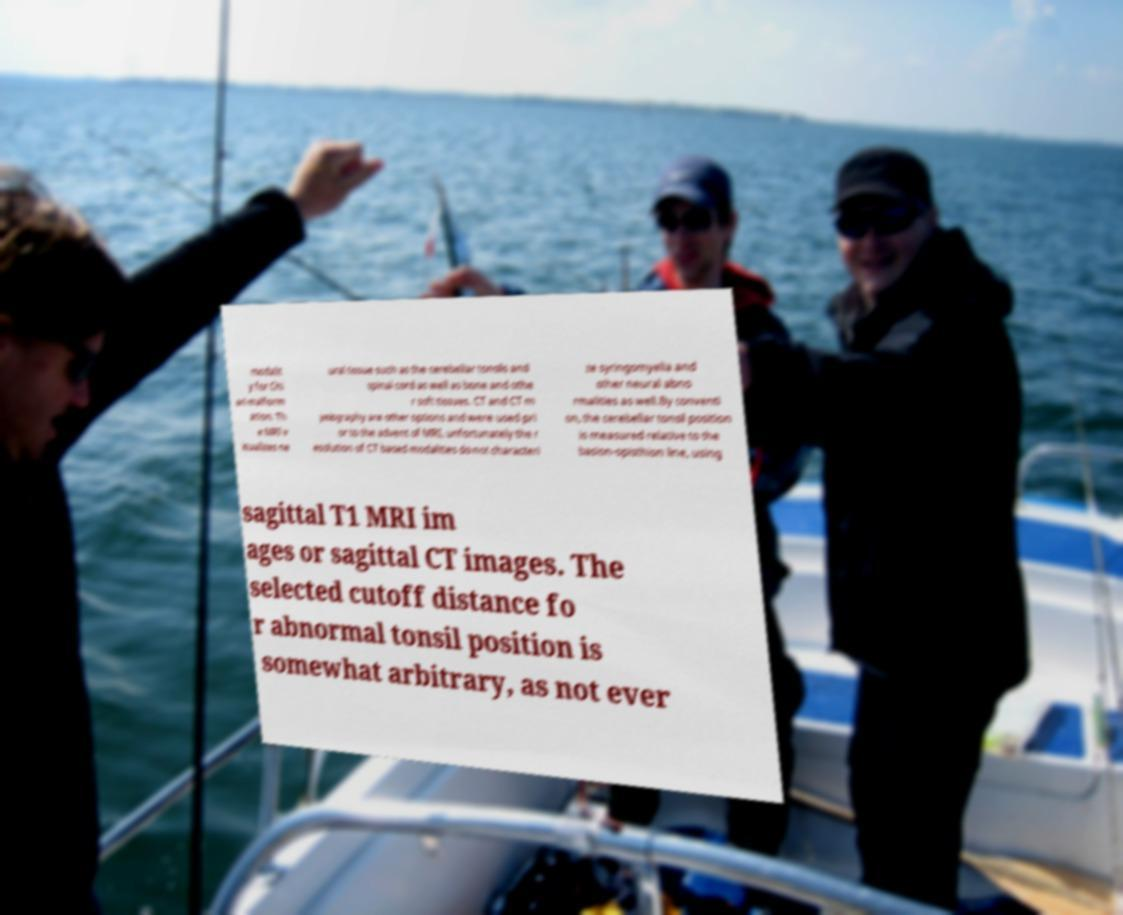Please read and relay the text visible in this image. What does it say? modalit y for Chi ari malform ation. Th e MRI v isualizes ne ural tissue such as the cerebellar tonsils and spinal cord as well as bone and othe r soft tissues. CT and CT m yelography are other options and were used pri or to the advent of MRI, unfortunately the r esolution of CT based modalities do not characteri ze syringomyelia and other neural abno rmalities as well.By conventi on, the cerebellar tonsil position is measured relative to the basion-opisthion line, using sagittal T1 MRI im ages or sagittal CT images. The selected cutoff distance fo r abnormal tonsil position is somewhat arbitrary, as not ever 